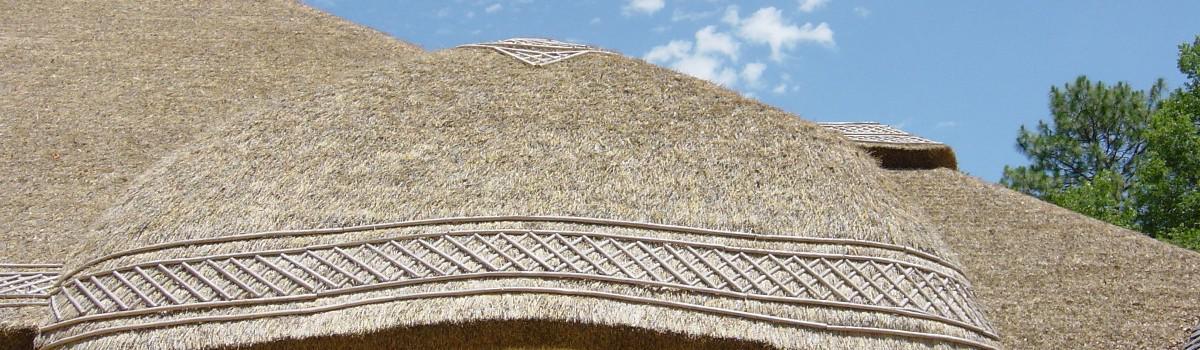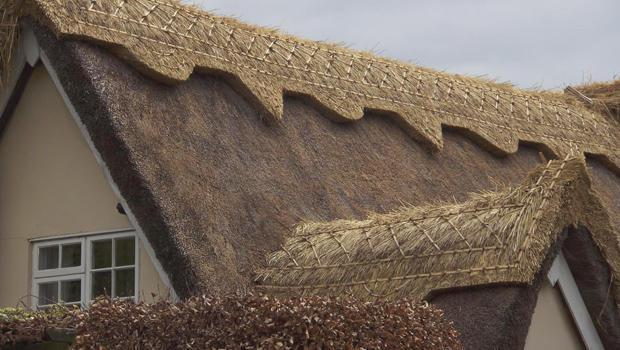The first image is the image on the left, the second image is the image on the right. Assess this claim about the two images: "A man is standing on the roof in one of the images.". Correct or not? Answer yes or no. No. The first image is the image on the left, the second image is the image on the right. Analyze the images presented: Is the assertion "There is at least one aluminum ladder leaning against a thatched roof." valid? Answer yes or no. No. 